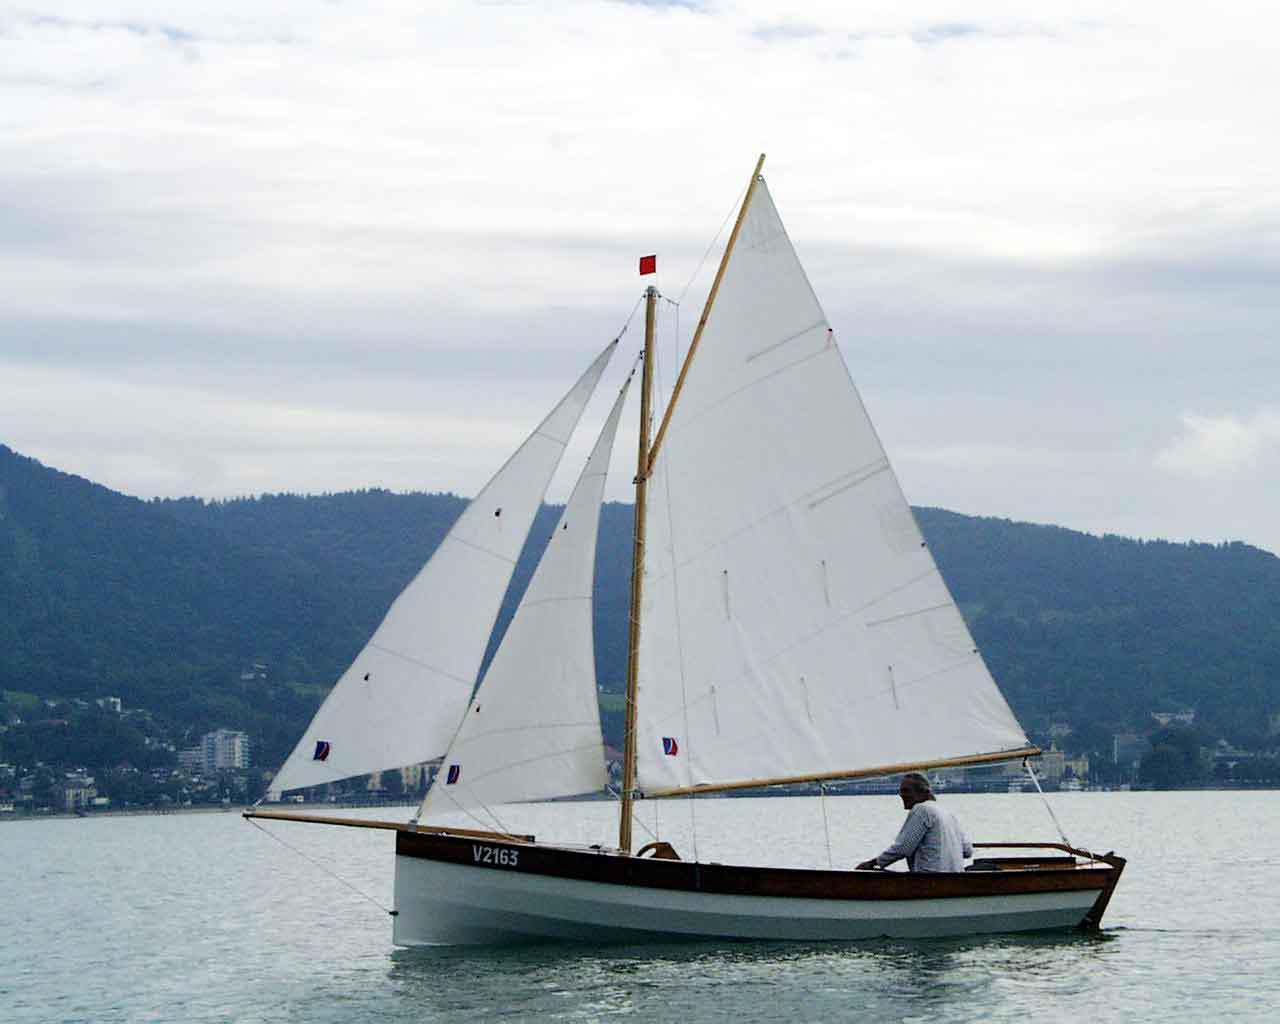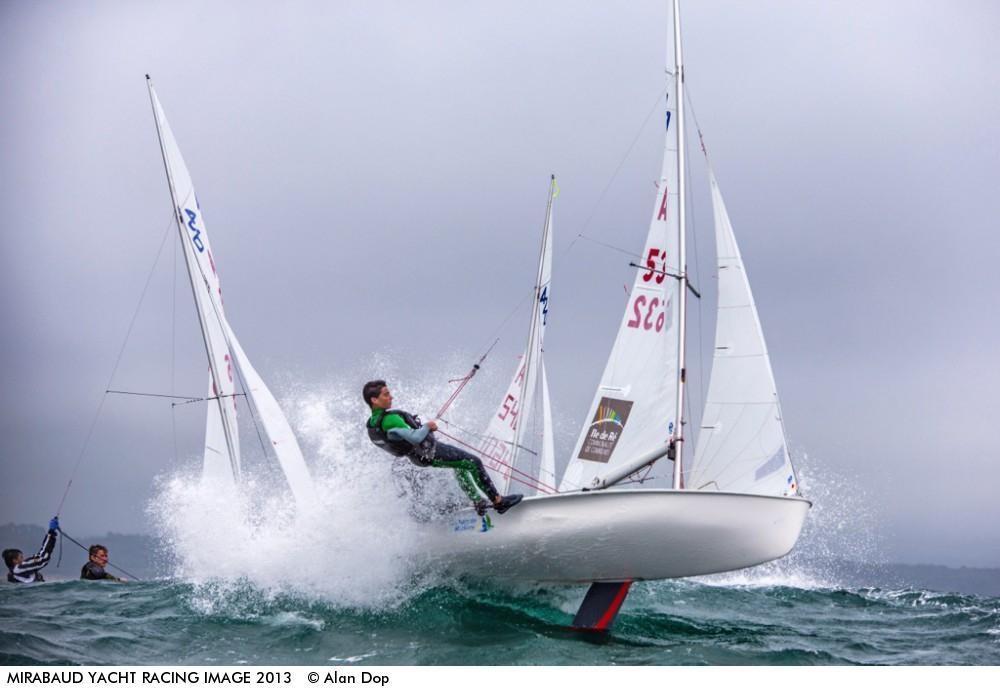The first image is the image on the left, the second image is the image on the right. For the images displayed, is the sentence "There is atleast one boat with numbers or letters on the sail" factually correct? Answer yes or no. Yes. 